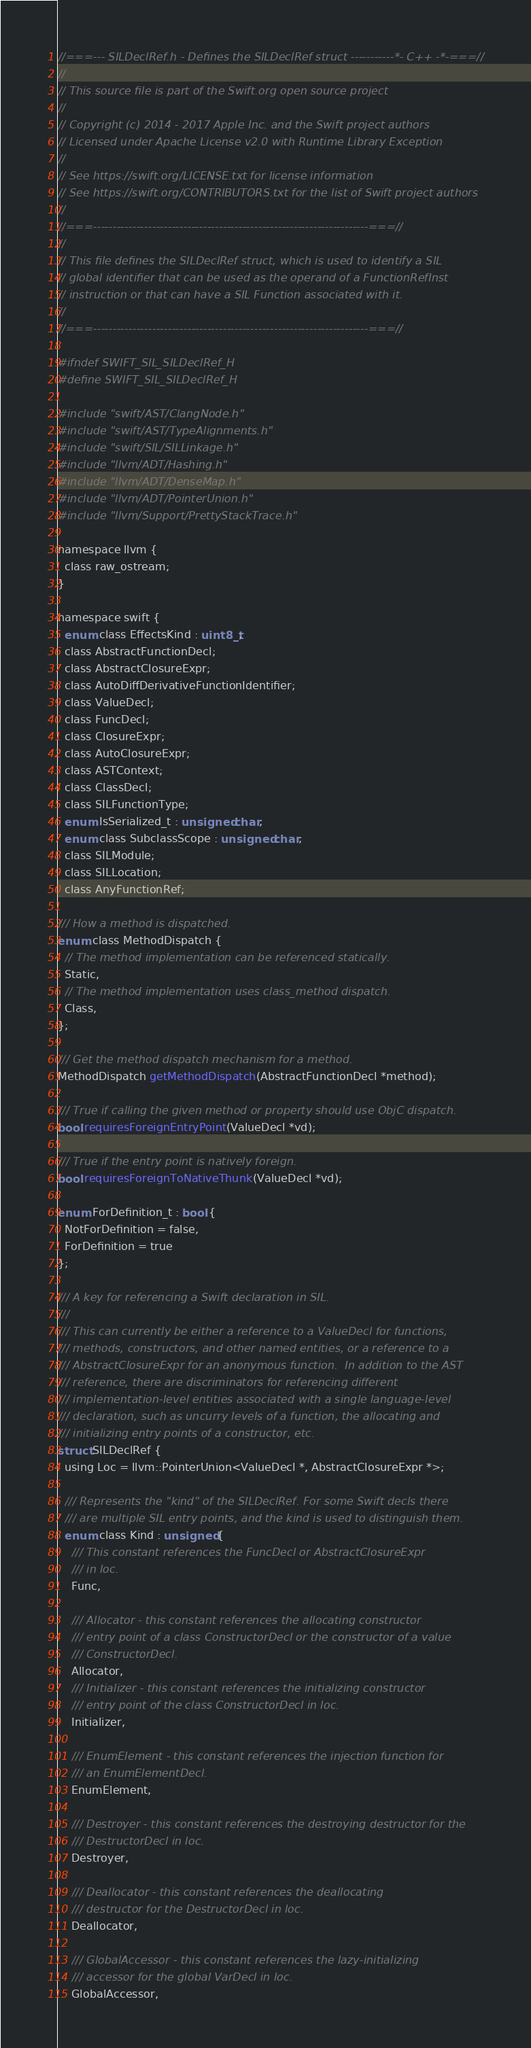<code> <loc_0><loc_0><loc_500><loc_500><_C_>//===--- SILDeclRef.h - Defines the SILDeclRef struct -----------*- C++ -*-===//
//
// This source file is part of the Swift.org open source project
//
// Copyright (c) 2014 - 2017 Apple Inc. and the Swift project authors
// Licensed under Apache License v2.0 with Runtime Library Exception
//
// See https://swift.org/LICENSE.txt for license information
// See https://swift.org/CONTRIBUTORS.txt for the list of Swift project authors
//
//===----------------------------------------------------------------------===//
//
// This file defines the SILDeclRef struct, which is used to identify a SIL
// global identifier that can be used as the operand of a FunctionRefInst
// instruction or that can have a SIL Function associated with it.
//
//===----------------------------------------------------------------------===//

#ifndef SWIFT_SIL_SILDeclRef_H
#define SWIFT_SIL_SILDeclRef_H

#include "swift/AST/ClangNode.h"
#include "swift/AST/TypeAlignments.h"
#include "swift/SIL/SILLinkage.h"
#include "llvm/ADT/Hashing.h"
#include "llvm/ADT/DenseMap.h"
#include "llvm/ADT/PointerUnion.h"
#include "llvm/Support/PrettyStackTrace.h"

namespace llvm {
  class raw_ostream;
}

namespace swift {
  enum class EffectsKind : uint8_t;
  class AbstractFunctionDecl;
  class AbstractClosureExpr;
  class AutoDiffDerivativeFunctionIdentifier;
  class ValueDecl;
  class FuncDecl;
  class ClosureExpr;
  class AutoClosureExpr;
  class ASTContext;
  class ClassDecl;
  class SILFunctionType;
  enum IsSerialized_t : unsigned char;
  enum class SubclassScope : unsigned char;
  class SILModule;
  class SILLocation;
  class AnyFunctionRef;

/// How a method is dispatched.
enum class MethodDispatch {
  // The method implementation can be referenced statically.
  Static,
  // The method implementation uses class_method dispatch.
  Class,
};

/// Get the method dispatch mechanism for a method.
MethodDispatch getMethodDispatch(AbstractFunctionDecl *method);

/// True if calling the given method or property should use ObjC dispatch.
bool requiresForeignEntryPoint(ValueDecl *vd);

/// True if the entry point is natively foreign.
bool requiresForeignToNativeThunk(ValueDecl *vd);

enum ForDefinition_t : bool {
  NotForDefinition = false,
  ForDefinition = true
};

/// A key for referencing a Swift declaration in SIL.
///
/// This can currently be either a reference to a ValueDecl for functions,
/// methods, constructors, and other named entities, or a reference to a
/// AbstractClosureExpr for an anonymous function.  In addition to the AST
/// reference, there are discriminators for referencing different
/// implementation-level entities associated with a single language-level
/// declaration, such as uncurry levels of a function, the allocating and
/// initializing entry points of a constructor, etc.
struct SILDeclRef {
  using Loc = llvm::PointerUnion<ValueDecl *, AbstractClosureExpr *>;

  /// Represents the "kind" of the SILDeclRef. For some Swift decls there
  /// are multiple SIL entry points, and the kind is used to distinguish them.
  enum class Kind : unsigned {
    /// This constant references the FuncDecl or AbstractClosureExpr
    /// in loc.
    Func,

    /// Allocator - this constant references the allocating constructor
    /// entry point of a class ConstructorDecl or the constructor of a value
    /// ConstructorDecl.
    Allocator,
    /// Initializer - this constant references the initializing constructor
    /// entry point of the class ConstructorDecl in loc.
    Initializer,
    
    /// EnumElement - this constant references the injection function for
    /// an EnumElementDecl.
    EnumElement,
    
    /// Destroyer - this constant references the destroying destructor for the
    /// DestructorDecl in loc.
    Destroyer,

    /// Deallocator - this constant references the deallocating
    /// destructor for the DestructorDecl in loc.
    Deallocator,
    
    /// GlobalAccessor - this constant references the lazy-initializing
    /// accessor for the global VarDecl in loc.
    GlobalAccessor,
</code> 